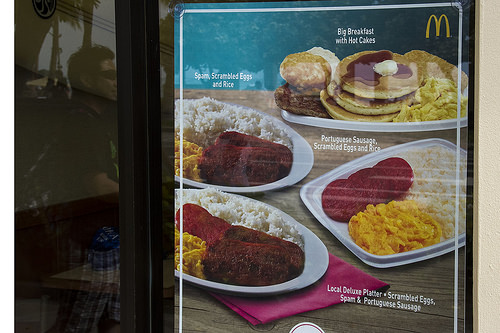<image>
Is the food on the plate? Yes. Looking at the image, I can see the food is positioned on top of the plate, with the plate providing support. Is the scrambled eggs in the plate? Yes. The scrambled eggs is contained within or inside the plate, showing a containment relationship. 